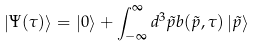<formula> <loc_0><loc_0><loc_500><loc_500>\left | \Psi ( \tau ) \right \rangle = \left | 0 \right \rangle + \int _ { - \infty } ^ { \infty } d ^ { 3 } \tilde { p } b ( \tilde { p } , \tau ) \left | \tilde { p } \right \rangle</formula> 